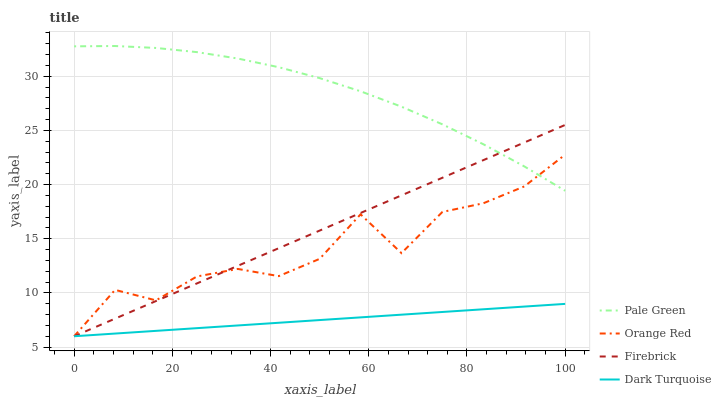Does Dark Turquoise have the minimum area under the curve?
Answer yes or no. Yes. Does Pale Green have the maximum area under the curve?
Answer yes or no. Yes. Does Firebrick have the minimum area under the curve?
Answer yes or no. No. Does Firebrick have the maximum area under the curve?
Answer yes or no. No. Is Dark Turquoise the smoothest?
Answer yes or no. Yes. Is Orange Red the roughest?
Answer yes or no. Yes. Is Firebrick the smoothest?
Answer yes or no. No. Is Firebrick the roughest?
Answer yes or no. No. Does Dark Turquoise have the lowest value?
Answer yes or no. Yes. Does Pale Green have the lowest value?
Answer yes or no. No. Does Pale Green have the highest value?
Answer yes or no. Yes. Does Firebrick have the highest value?
Answer yes or no. No. Is Dark Turquoise less than Pale Green?
Answer yes or no. Yes. Is Pale Green greater than Dark Turquoise?
Answer yes or no. Yes. Does Firebrick intersect Pale Green?
Answer yes or no. Yes. Is Firebrick less than Pale Green?
Answer yes or no. No. Is Firebrick greater than Pale Green?
Answer yes or no. No. Does Dark Turquoise intersect Pale Green?
Answer yes or no. No. 